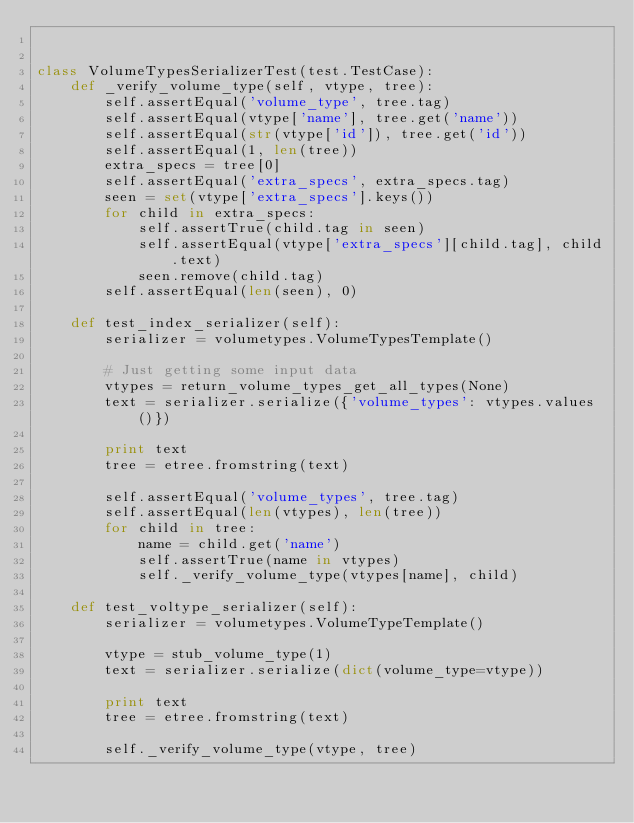Convert code to text. <code><loc_0><loc_0><loc_500><loc_500><_Python_>

class VolumeTypesSerializerTest(test.TestCase):
    def _verify_volume_type(self, vtype, tree):
        self.assertEqual('volume_type', tree.tag)
        self.assertEqual(vtype['name'], tree.get('name'))
        self.assertEqual(str(vtype['id']), tree.get('id'))
        self.assertEqual(1, len(tree))
        extra_specs = tree[0]
        self.assertEqual('extra_specs', extra_specs.tag)
        seen = set(vtype['extra_specs'].keys())
        for child in extra_specs:
            self.assertTrue(child.tag in seen)
            self.assertEqual(vtype['extra_specs'][child.tag], child.text)
            seen.remove(child.tag)
        self.assertEqual(len(seen), 0)

    def test_index_serializer(self):
        serializer = volumetypes.VolumeTypesTemplate()

        # Just getting some input data
        vtypes = return_volume_types_get_all_types(None)
        text = serializer.serialize({'volume_types': vtypes.values()})

        print text
        tree = etree.fromstring(text)

        self.assertEqual('volume_types', tree.tag)
        self.assertEqual(len(vtypes), len(tree))
        for child in tree:
            name = child.get('name')
            self.assertTrue(name in vtypes)
            self._verify_volume_type(vtypes[name], child)

    def test_voltype_serializer(self):
        serializer = volumetypes.VolumeTypeTemplate()

        vtype = stub_volume_type(1)
        text = serializer.serialize(dict(volume_type=vtype))

        print text
        tree = etree.fromstring(text)

        self._verify_volume_type(vtype, tree)
</code> 